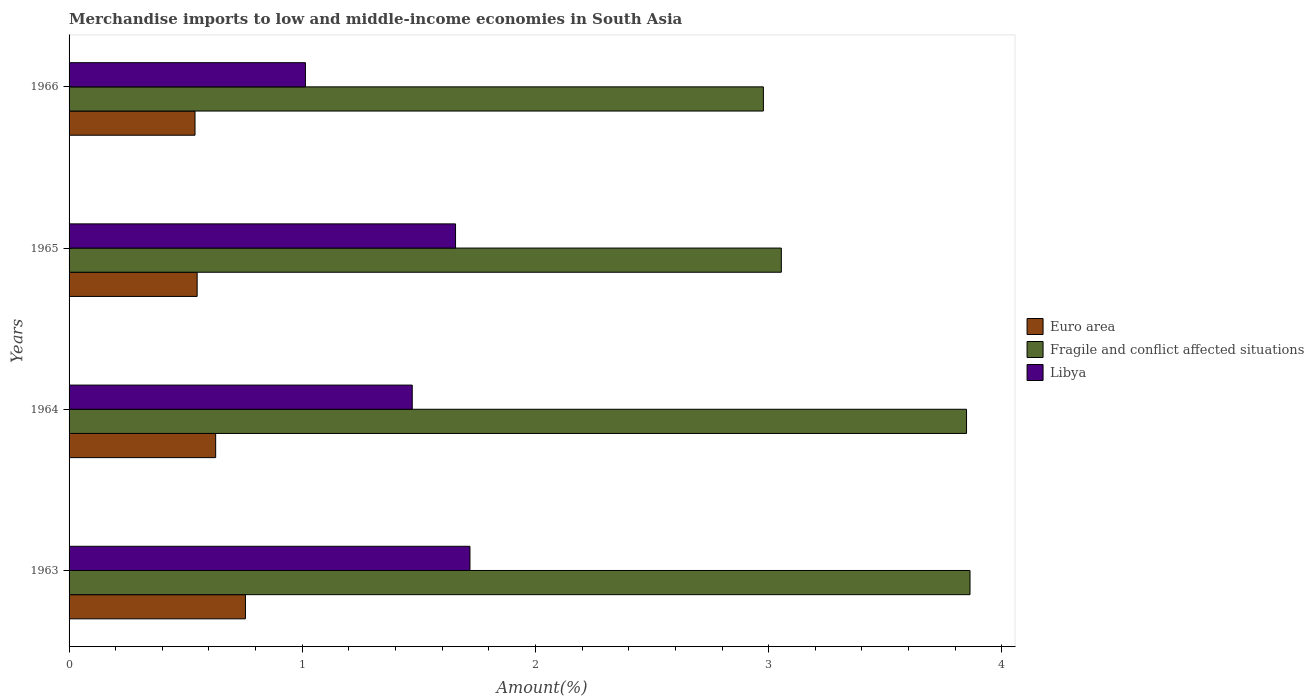Are the number of bars on each tick of the Y-axis equal?
Make the answer very short. Yes. How many bars are there on the 2nd tick from the top?
Provide a short and direct response. 3. How many bars are there on the 1st tick from the bottom?
Provide a succinct answer. 3. What is the label of the 2nd group of bars from the top?
Keep it short and to the point. 1965. In how many cases, is the number of bars for a given year not equal to the number of legend labels?
Make the answer very short. 0. What is the percentage of amount earned from merchandise imports in Fragile and conflict affected situations in 1964?
Ensure brevity in your answer.  3.85. Across all years, what is the maximum percentage of amount earned from merchandise imports in Euro area?
Provide a succinct answer. 0.76. Across all years, what is the minimum percentage of amount earned from merchandise imports in Libya?
Your answer should be compact. 1.01. In which year was the percentage of amount earned from merchandise imports in Fragile and conflict affected situations minimum?
Give a very brief answer. 1966. What is the total percentage of amount earned from merchandise imports in Euro area in the graph?
Keep it short and to the point. 2.47. What is the difference between the percentage of amount earned from merchandise imports in Libya in 1963 and that in 1964?
Keep it short and to the point. 0.25. What is the difference between the percentage of amount earned from merchandise imports in Libya in 1966 and the percentage of amount earned from merchandise imports in Euro area in 1965?
Your response must be concise. 0.46. What is the average percentage of amount earned from merchandise imports in Euro area per year?
Your response must be concise. 0.62. In the year 1966, what is the difference between the percentage of amount earned from merchandise imports in Libya and percentage of amount earned from merchandise imports in Fragile and conflict affected situations?
Give a very brief answer. -1.96. What is the ratio of the percentage of amount earned from merchandise imports in Fragile and conflict affected situations in 1964 to that in 1966?
Give a very brief answer. 1.29. Is the percentage of amount earned from merchandise imports in Fragile and conflict affected situations in 1965 less than that in 1966?
Offer a terse response. No. Is the difference between the percentage of amount earned from merchandise imports in Libya in 1964 and 1966 greater than the difference between the percentage of amount earned from merchandise imports in Fragile and conflict affected situations in 1964 and 1966?
Provide a short and direct response. No. What is the difference between the highest and the second highest percentage of amount earned from merchandise imports in Euro area?
Offer a very short reply. 0.13. What is the difference between the highest and the lowest percentage of amount earned from merchandise imports in Fragile and conflict affected situations?
Offer a very short reply. 0.89. Is the sum of the percentage of amount earned from merchandise imports in Euro area in 1964 and 1965 greater than the maximum percentage of amount earned from merchandise imports in Fragile and conflict affected situations across all years?
Your answer should be very brief. No. What does the 2nd bar from the bottom in 1963 represents?
Your answer should be compact. Fragile and conflict affected situations. Does the graph contain any zero values?
Offer a terse response. No. Does the graph contain grids?
Your answer should be very brief. No. Where does the legend appear in the graph?
Your response must be concise. Center right. How are the legend labels stacked?
Your answer should be compact. Vertical. What is the title of the graph?
Your answer should be compact. Merchandise imports to low and middle-income economies in South Asia. What is the label or title of the X-axis?
Provide a short and direct response. Amount(%). What is the label or title of the Y-axis?
Provide a short and direct response. Years. What is the Amount(%) of Euro area in 1963?
Provide a short and direct response. 0.76. What is the Amount(%) in Fragile and conflict affected situations in 1963?
Ensure brevity in your answer.  3.86. What is the Amount(%) of Libya in 1963?
Give a very brief answer. 1.72. What is the Amount(%) in Euro area in 1964?
Offer a terse response. 0.63. What is the Amount(%) in Fragile and conflict affected situations in 1964?
Offer a terse response. 3.85. What is the Amount(%) of Libya in 1964?
Ensure brevity in your answer.  1.47. What is the Amount(%) in Euro area in 1965?
Give a very brief answer. 0.55. What is the Amount(%) in Fragile and conflict affected situations in 1965?
Offer a very short reply. 3.05. What is the Amount(%) of Libya in 1965?
Ensure brevity in your answer.  1.66. What is the Amount(%) of Euro area in 1966?
Your answer should be very brief. 0.54. What is the Amount(%) of Fragile and conflict affected situations in 1966?
Your answer should be compact. 2.98. What is the Amount(%) in Libya in 1966?
Your answer should be very brief. 1.01. Across all years, what is the maximum Amount(%) of Euro area?
Your response must be concise. 0.76. Across all years, what is the maximum Amount(%) of Fragile and conflict affected situations?
Offer a terse response. 3.86. Across all years, what is the maximum Amount(%) of Libya?
Give a very brief answer. 1.72. Across all years, what is the minimum Amount(%) of Euro area?
Make the answer very short. 0.54. Across all years, what is the minimum Amount(%) in Fragile and conflict affected situations?
Offer a terse response. 2.98. Across all years, what is the minimum Amount(%) of Libya?
Provide a short and direct response. 1.01. What is the total Amount(%) of Euro area in the graph?
Offer a terse response. 2.47. What is the total Amount(%) in Fragile and conflict affected situations in the graph?
Your answer should be compact. 13.74. What is the total Amount(%) in Libya in the graph?
Keep it short and to the point. 5.86. What is the difference between the Amount(%) of Euro area in 1963 and that in 1964?
Your answer should be compact. 0.13. What is the difference between the Amount(%) of Fragile and conflict affected situations in 1963 and that in 1964?
Your answer should be compact. 0.01. What is the difference between the Amount(%) of Libya in 1963 and that in 1964?
Your response must be concise. 0.25. What is the difference between the Amount(%) of Euro area in 1963 and that in 1965?
Ensure brevity in your answer.  0.21. What is the difference between the Amount(%) of Fragile and conflict affected situations in 1963 and that in 1965?
Provide a short and direct response. 0.81. What is the difference between the Amount(%) in Libya in 1963 and that in 1965?
Provide a succinct answer. 0.06. What is the difference between the Amount(%) of Euro area in 1963 and that in 1966?
Keep it short and to the point. 0.22. What is the difference between the Amount(%) in Fragile and conflict affected situations in 1963 and that in 1966?
Make the answer very short. 0.89. What is the difference between the Amount(%) of Libya in 1963 and that in 1966?
Your response must be concise. 0.71. What is the difference between the Amount(%) in Euro area in 1964 and that in 1965?
Keep it short and to the point. 0.08. What is the difference between the Amount(%) in Fragile and conflict affected situations in 1964 and that in 1965?
Ensure brevity in your answer.  0.79. What is the difference between the Amount(%) in Libya in 1964 and that in 1965?
Provide a succinct answer. -0.19. What is the difference between the Amount(%) in Euro area in 1964 and that in 1966?
Offer a very short reply. 0.09. What is the difference between the Amount(%) of Fragile and conflict affected situations in 1964 and that in 1966?
Provide a succinct answer. 0.87. What is the difference between the Amount(%) in Libya in 1964 and that in 1966?
Offer a terse response. 0.46. What is the difference between the Amount(%) of Euro area in 1965 and that in 1966?
Offer a terse response. 0.01. What is the difference between the Amount(%) in Fragile and conflict affected situations in 1965 and that in 1966?
Your answer should be very brief. 0.08. What is the difference between the Amount(%) in Libya in 1965 and that in 1966?
Provide a short and direct response. 0.64. What is the difference between the Amount(%) of Euro area in 1963 and the Amount(%) of Fragile and conflict affected situations in 1964?
Give a very brief answer. -3.09. What is the difference between the Amount(%) of Euro area in 1963 and the Amount(%) of Libya in 1964?
Offer a very short reply. -0.72. What is the difference between the Amount(%) in Fragile and conflict affected situations in 1963 and the Amount(%) in Libya in 1964?
Your response must be concise. 2.39. What is the difference between the Amount(%) in Euro area in 1963 and the Amount(%) in Fragile and conflict affected situations in 1965?
Make the answer very short. -2.3. What is the difference between the Amount(%) in Euro area in 1963 and the Amount(%) in Libya in 1965?
Your answer should be compact. -0.9. What is the difference between the Amount(%) in Fragile and conflict affected situations in 1963 and the Amount(%) in Libya in 1965?
Offer a very short reply. 2.21. What is the difference between the Amount(%) in Euro area in 1963 and the Amount(%) in Fragile and conflict affected situations in 1966?
Offer a very short reply. -2.22. What is the difference between the Amount(%) in Euro area in 1963 and the Amount(%) in Libya in 1966?
Ensure brevity in your answer.  -0.26. What is the difference between the Amount(%) of Fragile and conflict affected situations in 1963 and the Amount(%) of Libya in 1966?
Ensure brevity in your answer.  2.85. What is the difference between the Amount(%) in Euro area in 1964 and the Amount(%) in Fragile and conflict affected situations in 1965?
Ensure brevity in your answer.  -2.43. What is the difference between the Amount(%) of Euro area in 1964 and the Amount(%) of Libya in 1965?
Ensure brevity in your answer.  -1.03. What is the difference between the Amount(%) in Fragile and conflict affected situations in 1964 and the Amount(%) in Libya in 1965?
Give a very brief answer. 2.19. What is the difference between the Amount(%) in Euro area in 1964 and the Amount(%) in Fragile and conflict affected situations in 1966?
Offer a very short reply. -2.35. What is the difference between the Amount(%) in Euro area in 1964 and the Amount(%) in Libya in 1966?
Your answer should be compact. -0.39. What is the difference between the Amount(%) of Fragile and conflict affected situations in 1964 and the Amount(%) of Libya in 1966?
Offer a terse response. 2.83. What is the difference between the Amount(%) of Euro area in 1965 and the Amount(%) of Fragile and conflict affected situations in 1966?
Keep it short and to the point. -2.43. What is the difference between the Amount(%) of Euro area in 1965 and the Amount(%) of Libya in 1966?
Provide a short and direct response. -0.46. What is the difference between the Amount(%) of Fragile and conflict affected situations in 1965 and the Amount(%) of Libya in 1966?
Make the answer very short. 2.04. What is the average Amount(%) in Euro area per year?
Offer a very short reply. 0.62. What is the average Amount(%) of Fragile and conflict affected situations per year?
Your response must be concise. 3.44. What is the average Amount(%) of Libya per year?
Make the answer very short. 1.47. In the year 1963, what is the difference between the Amount(%) of Euro area and Amount(%) of Fragile and conflict affected situations?
Offer a very short reply. -3.11. In the year 1963, what is the difference between the Amount(%) in Euro area and Amount(%) in Libya?
Provide a short and direct response. -0.96. In the year 1963, what is the difference between the Amount(%) of Fragile and conflict affected situations and Amount(%) of Libya?
Your response must be concise. 2.14. In the year 1964, what is the difference between the Amount(%) of Euro area and Amount(%) of Fragile and conflict affected situations?
Your answer should be compact. -3.22. In the year 1964, what is the difference between the Amount(%) in Euro area and Amount(%) in Libya?
Offer a very short reply. -0.84. In the year 1964, what is the difference between the Amount(%) of Fragile and conflict affected situations and Amount(%) of Libya?
Your response must be concise. 2.38. In the year 1965, what is the difference between the Amount(%) of Euro area and Amount(%) of Fragile and conflict affected situations?
Provide a short and direct response. -2.51. In the year 1965, what is the difference between the Amount(%) in Euro area and Amount(%) in Libya?
Provide a succinct answer. -1.11. In the year 1965, what is the difference between the Amount(%) in Fragile and conflict affected situations and Amount(%) in Libya?
Keep it short and to the point. 1.4. In the year 1966, what is the difference between the Amount(%) of Euro area and Amount(%) of Fragile and conflict affected situations?
Your answer should be compact. -2.44. In the year 1966, what is the difference between the Amount(%) of Euro area and Amount(%) of Libya?
Give a very brief answer. -0.47. In the year 1966, what is the difference between the Amount(%) of Fragile and conflict affected situations and Amount(%) of Libya?
Your response must be concise. 1.96. What is the ratio of the Amount(%) in Euro area in 1963 to that in 1964?
Keep it short and to the point. 1.2. What is the ratio of the Amount(%) in Fragile and conflict affected situations in 1963 to that in 1964?
Your answer should be compact. 1. What is the ratio of the Amount(%) in Libya in 1963 to that in 1964?
Your answer should be very brief. 1.17. What is the ratio of the Amount(%) in Euro area in 1963 to that in 1965?
Make the answer very short. 1.38. What is the ratio of the Amount(%) in Fragile and conflict affected situations in 1963 to that in 1965?
Give a very brief answer. 1.26. What is the ratio of the Amount(%) of Libya in 1963 to that in 1965?
Your response must be concise. 1.04. What is the ratio of the Amount(%) of Euro area in 1963 to that in 1966?
Provide a succinct answer. 1.4. What is the ratio of the Amount(%) of Fragile and conflict affected situations in 1963 to that in 1966?
Make the answer very short. 1.3. What is the ratio of the Amount(%) of Libya in 1963 to that in 1966?
Your answer should be very brief. 1.7. What is the ratio of the Amount(%) of Euro area in 1964 to that in 1965?
Your answer should be very brief. 1.14. What is the ratio of the Amount(%) of Fragile and conflict affected situations in 1964 to that in 1965?
Keep it short and to the point. 1.26. What is the ratio of the Amount(%) in Libya in 1964 to that in 1965?
Provide a short and direct response. 0.89. What is the ratio of the Amount(%) of Euro area in 1964 to that in 1966?
Your response must be concise. 1.16. What is the ratio of the Amount(%) of Fragile and conflict affected situations in 1964 to that in 1966?
Provide a succinct answer. 1.29. What is the ratio of the Amount(%) of Libya in 1964 to that in 1966?
Make the answer very short. 1.45. What is the ratio of the Amount(%) of Fragile and conflict affected situations in 1965 to that in 1966?
Offer a terse response. 1.03. What is the ratio of the Amount(%) in Libya in 1965 to that in 1966?
Offer a terse response. 1.64. What is the difference between the highest and the second highest Amount(%) in Euro area?
Your answer should be very brief. 0.13. What is the difference between the highest and the second highest Amount(%) in Fragile and conflict affected situations?
Give a very brief answer. 0.01. What is the difference between the highest and the second highest Amount(%) in Libya?
Provide a short and direct response. 0.06. What is the difference between the highest and the lowest Amount(%) in Euro area?
Ensure brevity in your answer.  0.22. What is the difference between the highest and the lowest Amount(%) in Fragile and conflict affected situations?
Offer a terse response. 0.89. What is the difference between the highest and the lowest Amount(%) of Libya?
Your answer should be very brief. 0.71. 